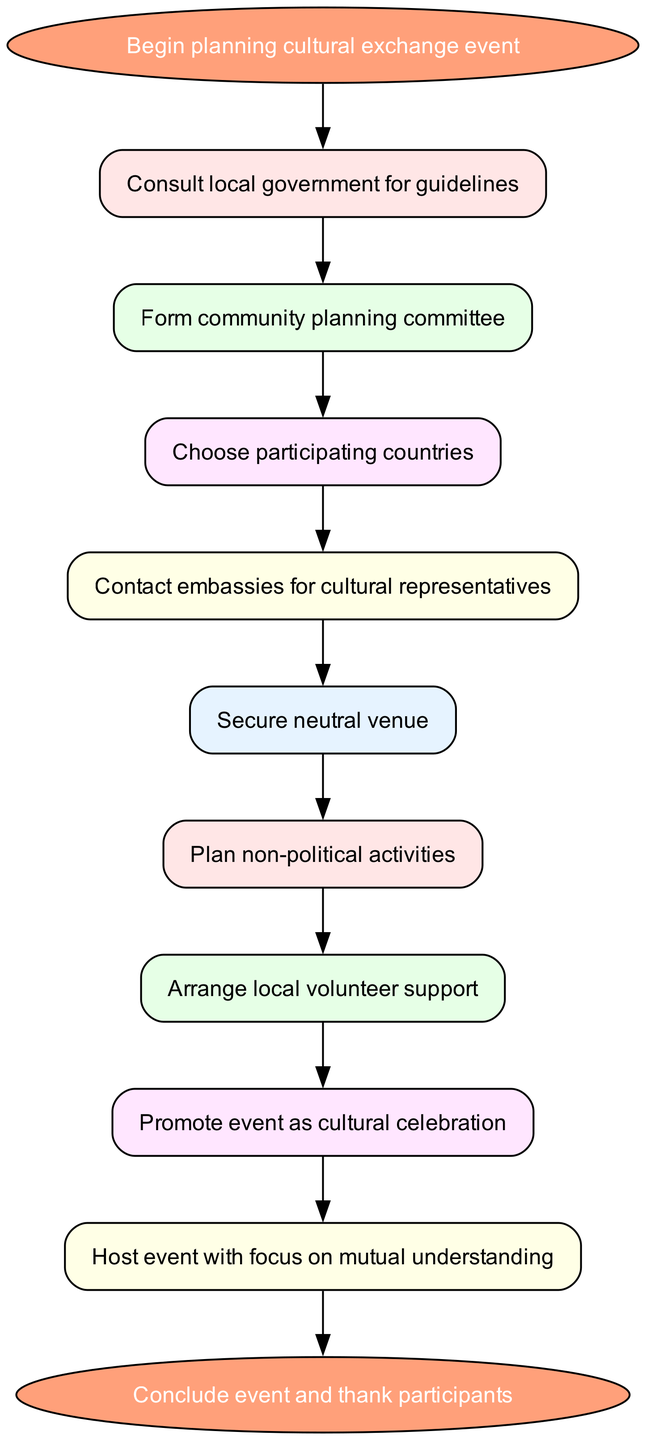What is the total number of nodes in the diagram? The diagram has 10 nodes, including the start and end nodes. They represent different steps in the procedure for hosting the event.
Answer: 10 What is the text in the node after "Form community planning committee"? The node immediately following "Form community planning committee" is "Choose participating countries," indicating the next step in the planning process.
Answer: Choose participating countries What is the last step in the process according to the diagram? The last step in the diagram is represented by the "Conclude event and thank participants" node, which occurs after hosting the event.
Answer: Conclude event and thank participants How many connections are there between nodes in the diagram? The diagram has 9 connections, which show the directional flow from one step to the next in the planning process for the cultural exchange event.
Answer: 9 What is the first action to take when starting to plan the event? The first action listed in the diagram is to "Consult local government for guidelines," indicating the importance of adhering to local regulations as the initial step.
Answer: Consult local government for guidelines Which nodes focus on community participation? The nodes that focus on community participation are "Form community planning committee," "Arrange local volunteer support," and "Host event with focus on mutual understanding," emphasizing local involvement throughout the process.
Answer: Form community planning committee, Arrange local volunteer support, Host event with focus on mutual understanding What is the purpose of the "Plan non-political activities" step? The purpose of the "Plan non-political activities" step is to ensure that the event fosters cultural exchange without political overtones, aligning with the goal of mutual understanding.
Answer: To ensure non-political engagement How does the diagram indicate the importance of promotion? The diagram highlights the promotion of the event as a "cultural celebration," which is a step to attract participants and create a welcoming atmosphere for cultural exchange.
Answer: Promote event as cultural celebration What step comes directly before hosting the event? The step that comes directly before hosting the event is "Promote event as cultural celebration," showing the importance of marketing before the actual event takes place.
Answer: Promote event as cultural celebration 